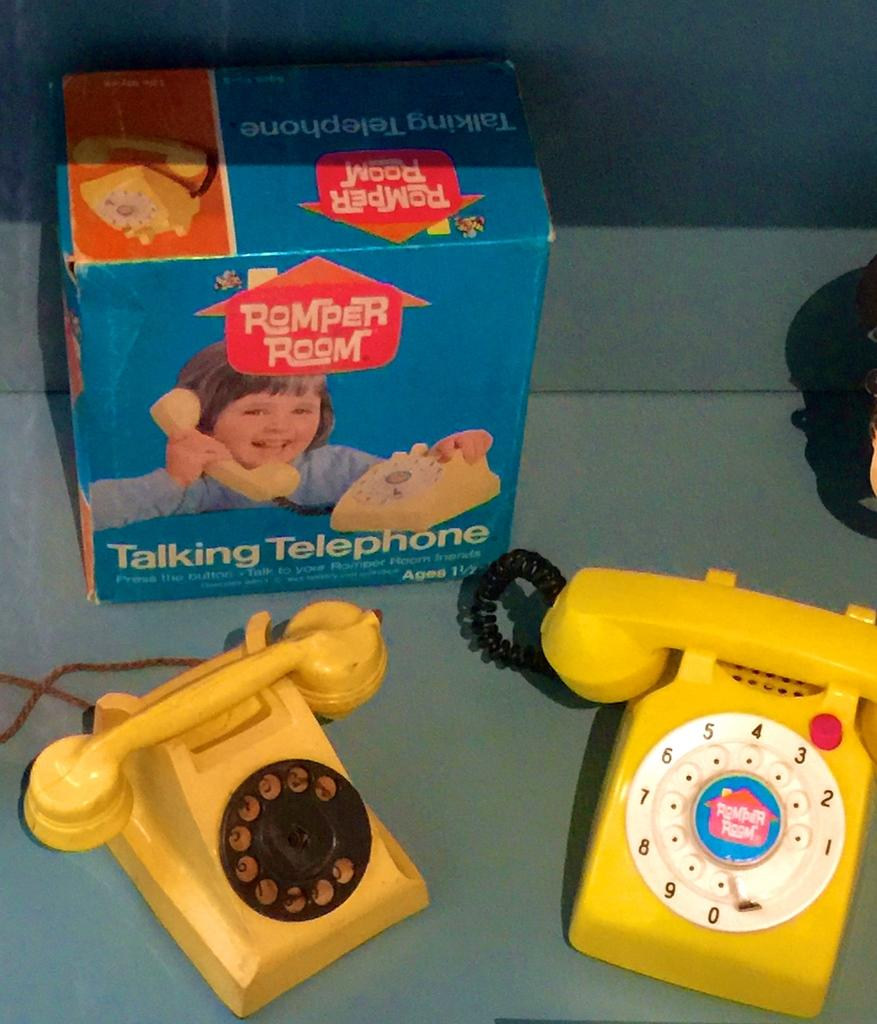<image>
Write a terse but informative summary of the picture. a romper room toy that is a fake telephone 